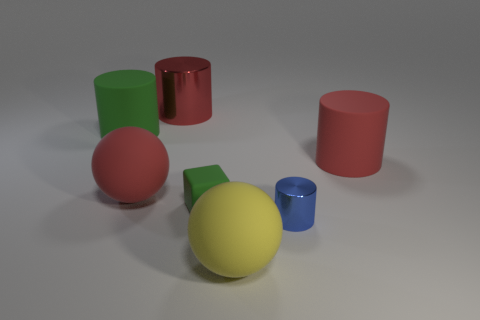There is a block that is the same size as the blue object; what is its color?
Give a very brief answer. Green. Is the number of tiny matte things that are left of the green rubber cylinder the same as the number of yellow metal cylinders?
Your answer should be compact. Yes. What is the color of the large sphere that is in front of the rubber ball that is to the left of the rubber block?
Your answer should be very brief. Yellow. How big is the object in front of the metallic cylinder in front of the big green matte object?
Give a very brief answer. Large. There is a cylinder that is the same color as the tiny matte thing; what size is it?
Your answer should be very brief. Large. How many other things are there of the same size as the yellow matte sphere?
Offer a terse response. 4. There is a large ball in front of the matte sphere that is behind the ball in front of the small green block; what color is it?
Your answer should be compact. Yellow. How many other things are the same shape as the yellow thing?
Offer a terse response. 1. The matte thing right of the yellow thing has what shape?
Offer a terse response. Cylinder. Are there any matte objects that are to the left of the large sphere that is behind the blue cylinder?
Your response must be concise. Yes. 